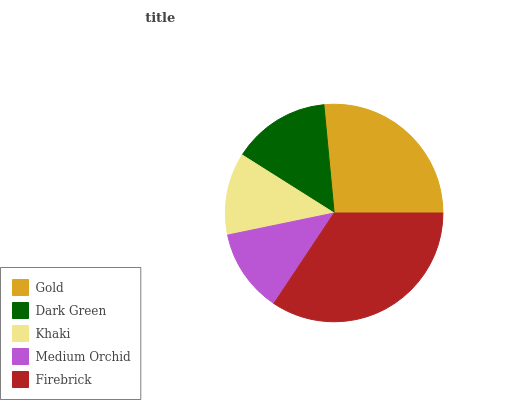Is Khaki the minimum?
Answer yes or no. Yes. Is Firebrick the maximum?
Answer yes or no. Yes. Is Dark Green the minimum?
Answer yes or no. No. Is Dark Green the maximum?
Answer yes or no. No. Is Gold greater than Dark Green?
Answer yes or no. Yes. Is Dark Green less than Gold?
Answer yes or no. Yes. Is Dark Green greater than Gold?
Answer yes or no. No. Is Gold less than Dark Green?
Answer yes or no. No. Is Dark Green the high median?
Answer yes or no. Yes. Is Dark Green the low median?
Answer yes or no. Yes. Is Khaki the high median?
Answer yes or no. No. Is Khaki the low median?
Answer yes or no. No. 